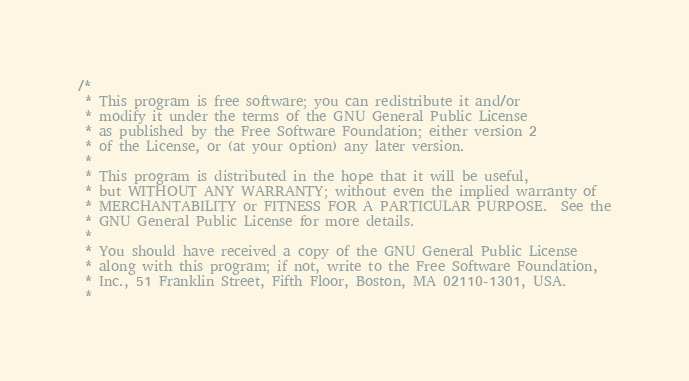<code> <loc_0><loc_0><loc_500><loc_500><_C_>/*
 * This program is free software; you can redistribute it and/or
 * modify it under the terms of the GNU General Public License
 * as published by the Free Software Foundation; either version 2
 * of the License, or (at your option) any later version.
 *
 * This program is distributed in the hope that it will be useful,
 * but WITHOUT ANY WARRANTY; without even the implied warranty of
 * MERCHANTABILITY or FITNESS FOR A PARTICULAR PURPOSE.  See the
 * GNU General Public License for more details.
 *
 * You should have received a copy of the GNU General Public License
 * along with this program; if not, write to the Free Software Foundation,
 * Inc., 51 Franklin Street, Fifth Floor, Boston, MA 02110-1301, USA.
 *</code> 